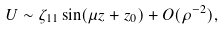Convert formula to latex. <formula><loc_0><loc_0><loc_500><loc_500>U \sim \zeta _ { 1 1 } \sin ( \mu z + z _ { 0 } ) + O ( \rho ^ { - 2 } ) ,</formula> 